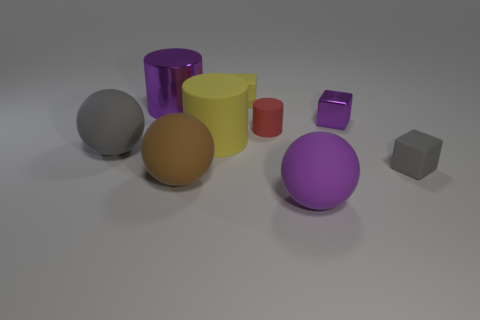What size is the ball that is the same color as the small metallic object?
Your answer should be very brief. Large. What material is the cube that is the same color as the large metallic thing?
Your answer should be very brief. Metal. There is a small metallic object that is left of the small rubber cube that is on the right side of the yellow thing behind the big purple shiny cylinder; what shape is it?
Provide a short and direct response. Cube. What is the shape of the purple thing that is both behind the purple ball and right of the large yellow matte cylinder?
Provide a succinct answer. Cube. There is a gray thing that is left of the yellow cube to the right of the brown rubber ball; what number of big purple rubber things are in front of it?
Make the answer very short. 1. What size is the gray object that is the same shape as the small yellow thing?
Give a very brief answer. Small. Is there any other thing that has the same size as the gray cube?
Ensure brevity in your answer.  Yes. Is the material of the big purple object on the left side of the purple rubber object the same as the red cylinder?
Provide a succinct answer. No. There is another big object that is the same shape as the big metal thing; what is its color?
Make the answer very short. Yellow. How many other things are the same color as the metallic cube?
Keep it short and to the point. 2. 